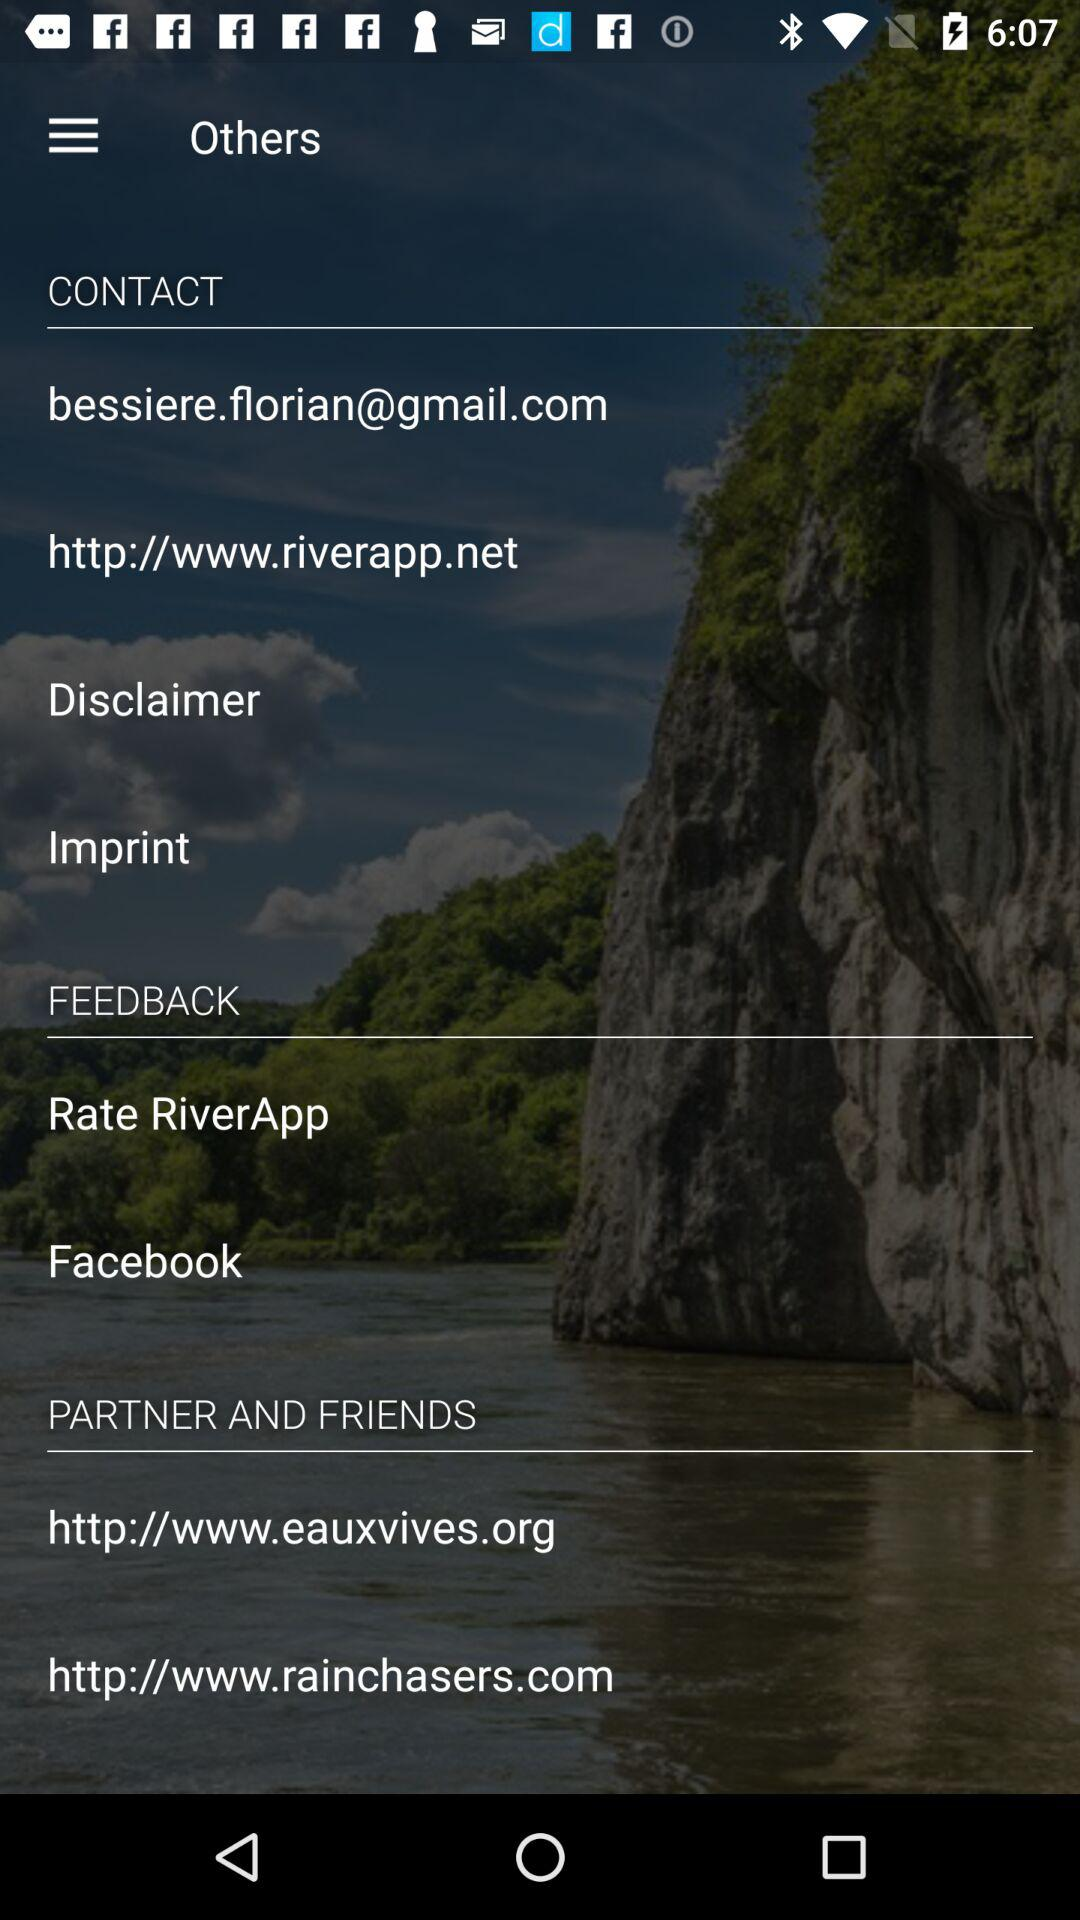What is the URL in "PARTNER AND FRIENDS"? The URLs are http://www.eauxvives.org and http://www.rainchasers.com. 